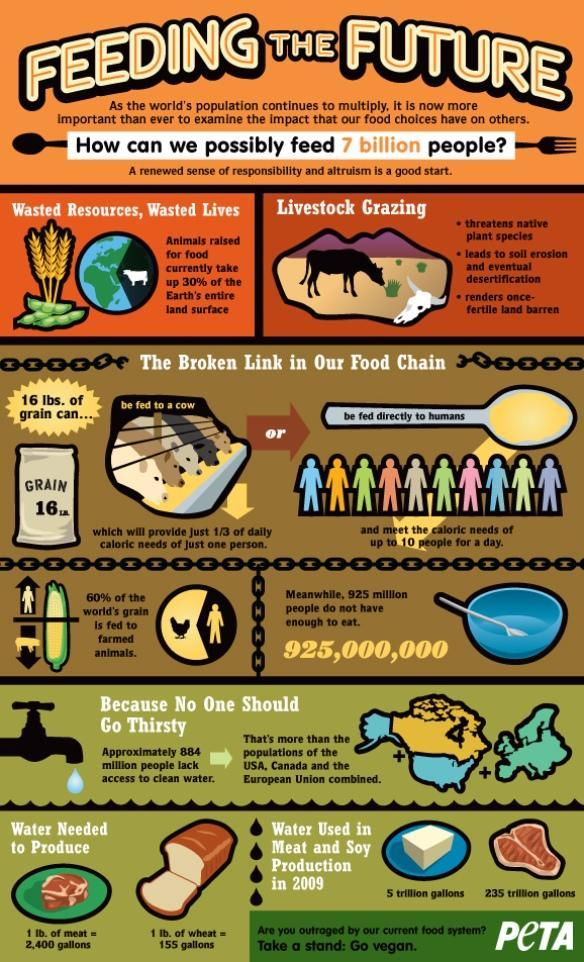What amount of water is needed to produce 1lb of wheat?
Answer the question with a short phrase. 155 gallons What percentage of the earth's entire land surface are not animals raised for food? 70% What percentage of the world's grain not fed to farmed animals? 40% What amount of water is needed to produce 1lb of meat? 2,400 gallons What amount of water is needed to produce soy in 2009? 235 trillion gallons 